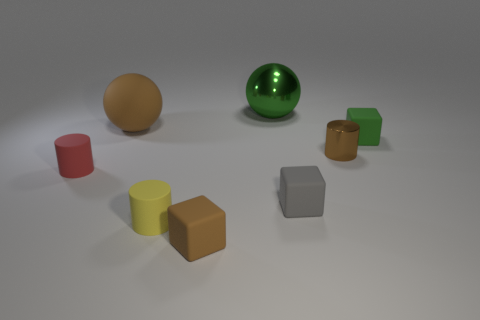What number of things are big green things or small matte blocks that are right of the green ball?
Provide a succinct answer. 3. There is a brown matte object that is in front of the small brown metallic thing; does it have the same size as the green block behind the red thing?
Your response must be concise. Yes. What number of other objects are the same color as the large rubber ball?
Ensure brevity in your answer.  2. There is a yellow cylinder; does it have the same size as the brown rubber object that is to the right of the small yellow thing?
Your answer should be very brief. Yes. What size is the matte cylinder that is on the left side of the brown matte object that is behind the yellow object?
Keep it short and to the point. Small. There is another small rubber object that is the same shape as the small yellow object; what is its color?
Make the answer very short. Red. Is the gray block the same size as the red rubber cylinder?
Provide a succinct answer. Yes. Is the number of brown matte spheres behind the big brown object the same as the number of big brown rubber things?
Your answer should be compact. No. Is there a large brown thing in front of the small brown thing that is to the right of the tiny brown cube?
Give a very brief answer. No. How big is the sphere that is in front of the shiny object behind the tiny green thing in front of the green ball?
Provide a succinct answer. Large. 